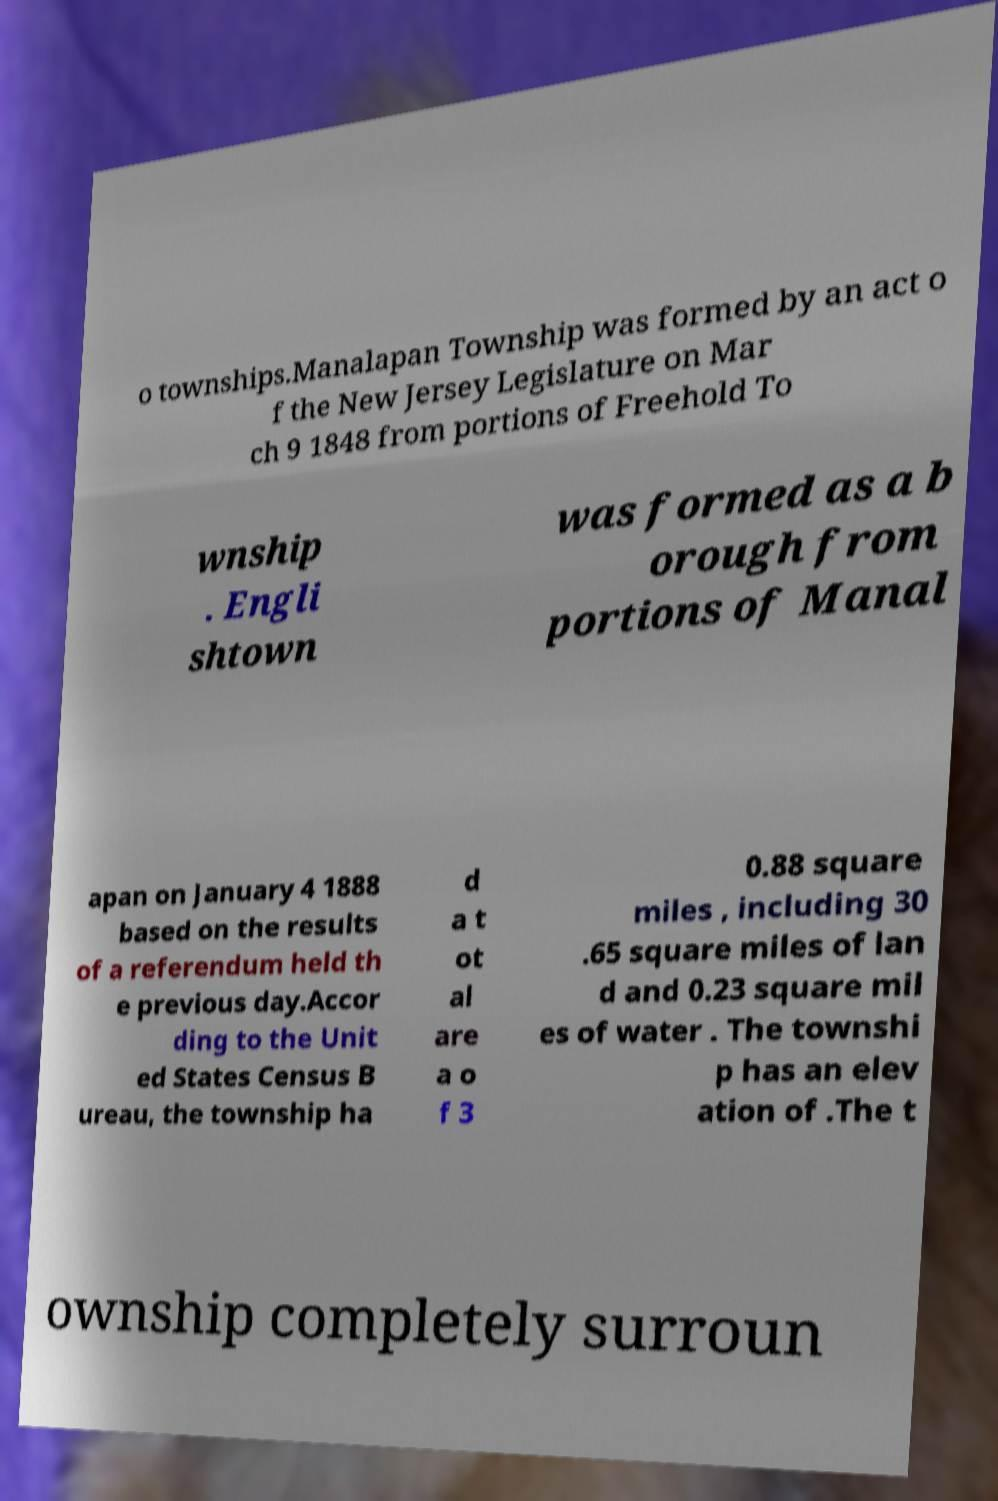For documentation purposes, I need the text within this image transcribed. Could you provide that? o townships.Manalapan Township was formed by an act o f the New Jersey Legislature on Mar ch 9 1848 from portions of Freehold To wnship . Engli shtown was formed as a b orough from portions of Manal apan on January 4 1888 based on the results of a referendum held th e previous day.Accor ding to the Unit ed States Census B ureau, the township ha d a t ot al are a o f 3 0.88 square miles , including 30 .65 square miles of lan d and 0.23 square mil es of water . The townshi p has an elev ation of .The t ownship completely surroun 